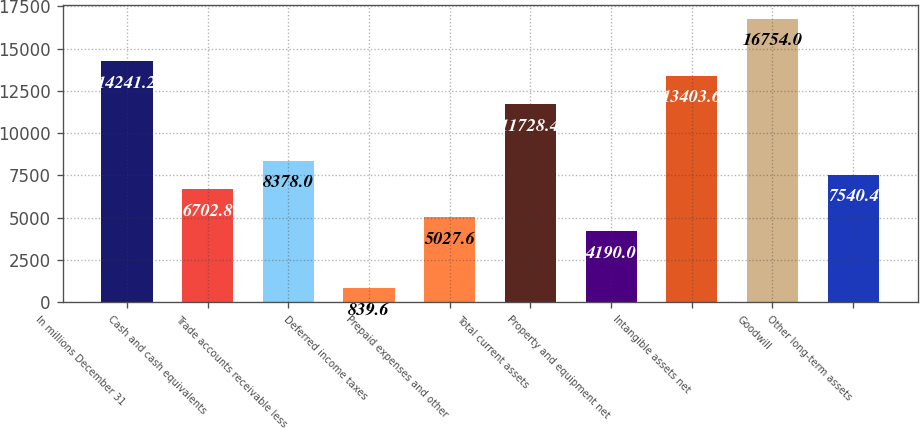Convert chart to OTSL. <chart><loc_0><loc_0><loc_500><loc_500><bar_chart><fcel>In millions December 31<fcel>Cash and cash equivalents<fcel>Trade accounts receivable less<fcel>Deferred income taxes<fcel>Prepaid expenses and other<fcel>Total current assets<fcel>Property and equipment net<fcel>Intangible assets net<fcel>Goodwill<fcel>Other long-term assets<nl><fcel>14241.2<fcel>6702.8<fcel>8378<fcel>839.6<fcel>5027.6<fcel>11728.4<fcel>4190<fcel>13403.6<fcel>16754<fcel>7540.4<nl></chart> 